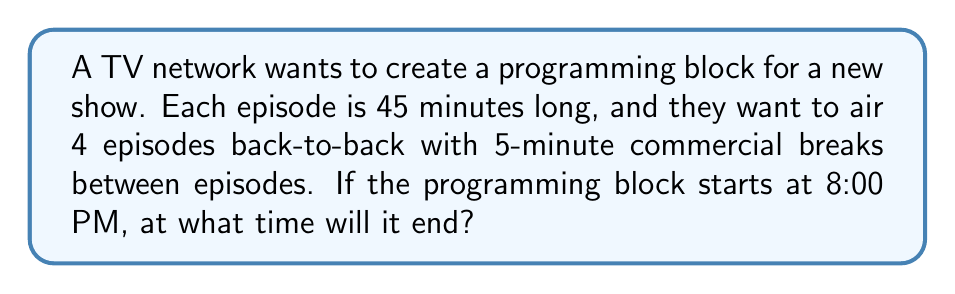Show me your answer to this math problem. Let's break this down step-by-step:

1. Calculate the total time for episodes:
   $$ 45 \text{ minutes} \times 4 \text{ episodes} = 180 \text{ minutes} $$

2. Calculate the total time for commercial breaks:
   There are 3 commercial breaks (between the 4 episodes)
   $$ 5 \text{ minutes} \times 3 \text{ breaks} = 15 \text{ minutes} $$

3. Sum up the total time for the programming block:
   $$ 180 \text{ minutes} + 15 \text{ minutes} = 195 \text{ minutes} $$

4. Convert 195 minutes to hours and minutes:
   $$ 195 \text{ minutes} = 3 \text{ hours and } 15 \text{ minutes} $$

5. Add this time to the start time (8:00 PM):
   8:00 PM + 3 hours = 11:00 PM
   11:00 PM + 15 minutes = 11:15 PM

Therefore, the programming block will end at 11:15 PM.
Answer: 11:15 PM 